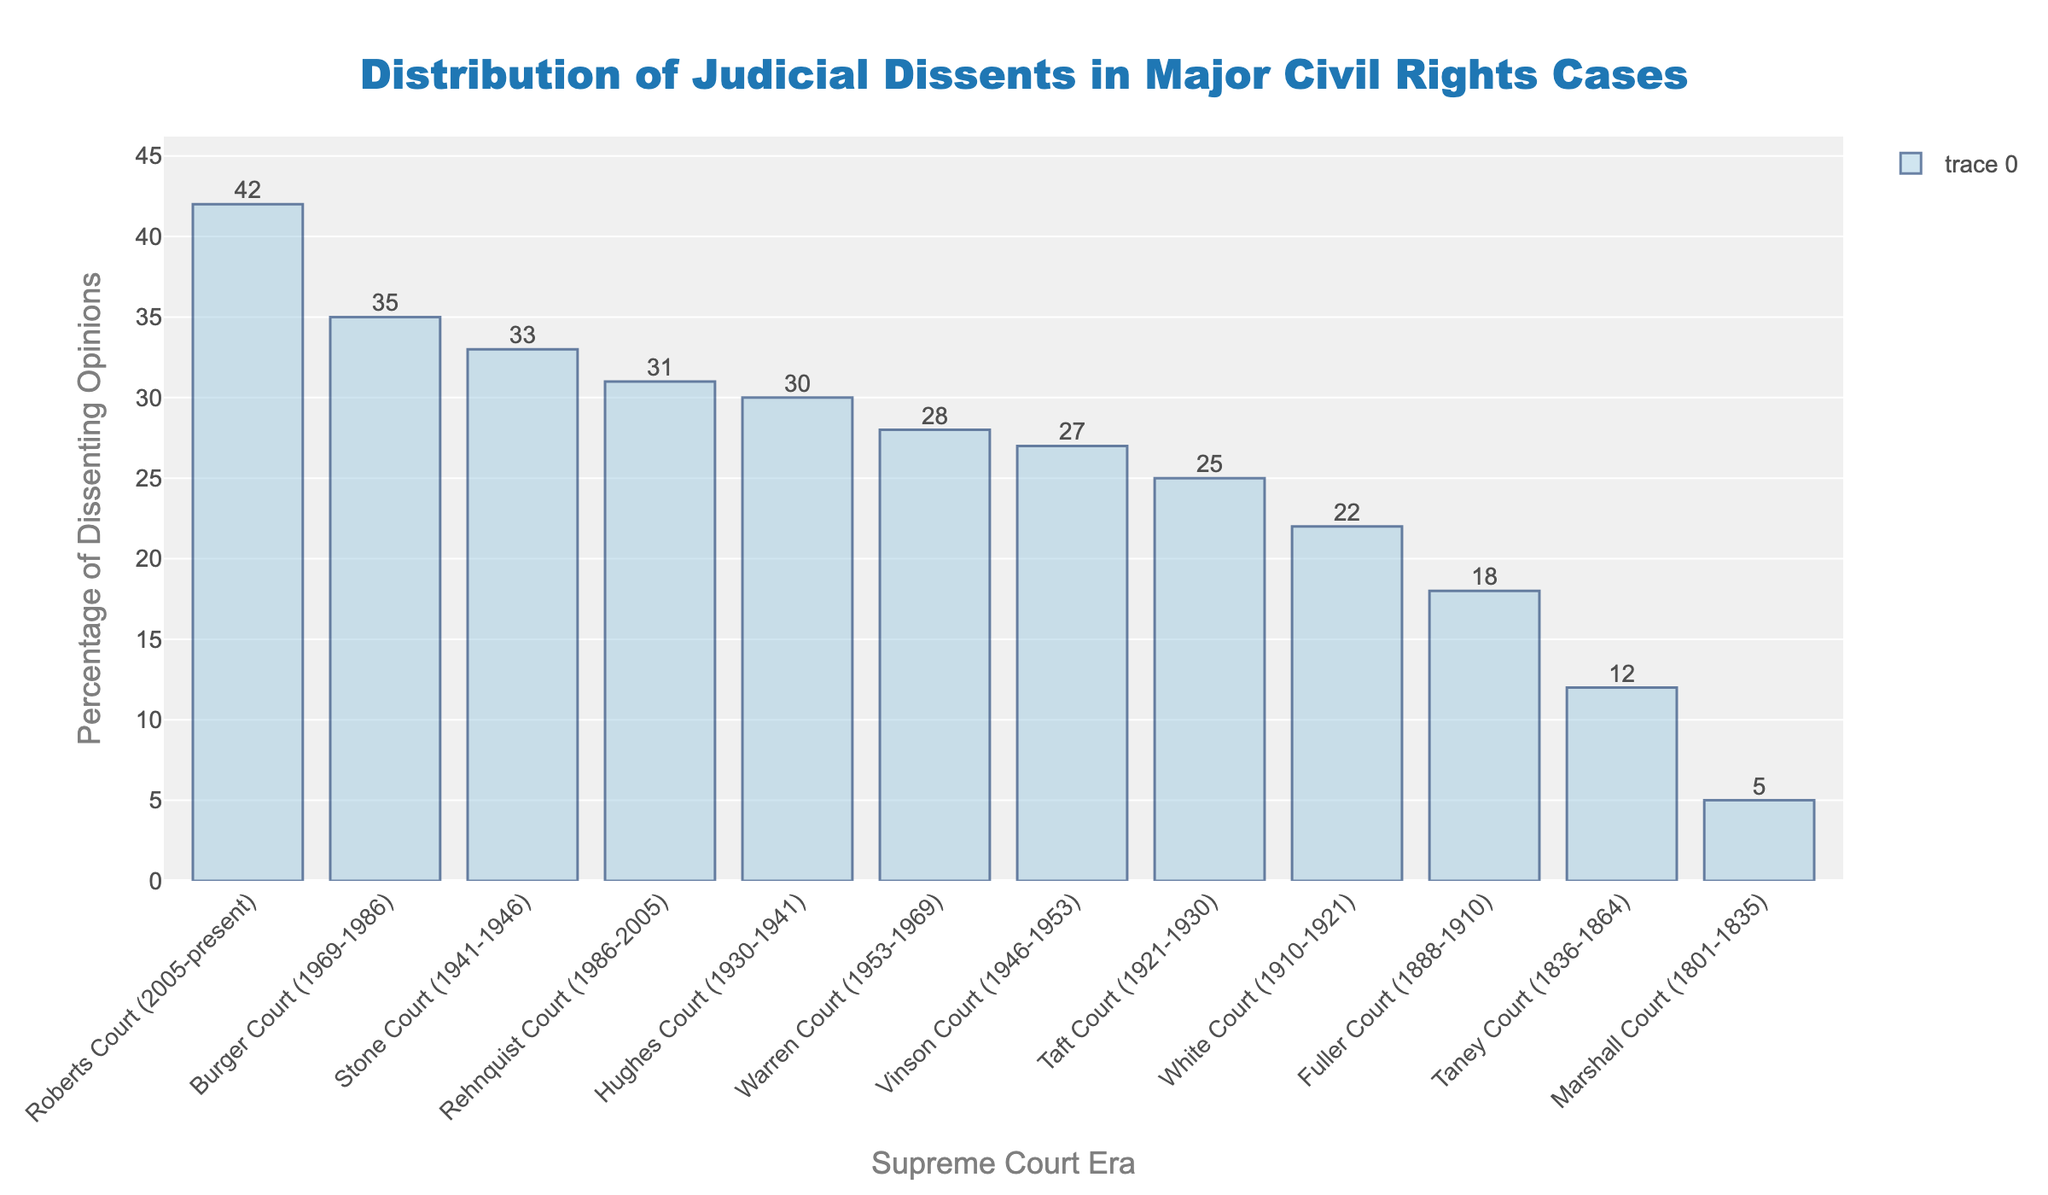Which Supreme Court era has the highest percentage of dissenting opinions? The highest bar in the chart represents the Roberts Court, with the label showing the percentage of dissenting opinions as 42%.
Answer: Roberts Court (2005-present) What is the difference in the percentage of dissenting opinions between the Warren Court and the Vinson Court? The chart shows the Warren Court has a percentage of 28% and the Vinson Court has 27%. The difference is calculated as 28 - 27.
Answer: 1% How does the percentage of dissenting opinions in the Rehnquist Court compare to the Hughes Court? According to the chart, the Rehnquist Court has a percentage of 31% while the Hughes Court has 30%. The Rehnquist Court has a slightly higher percentage than the Hughes Court.
Answer: The Rehnquist Court is 1% higher Which two Supreme Court eras have the closest percentage of dissenting opinions? By examining the chart, the Warren Court (28%) and the Vinson Court (27%) have the percentages that are closest to each other. The difference between their percentages is the smallest.
Answer: Warren Court and Vinson Court What is the combined percentage of dissenting opinions for the Marshall Court, Taney Court, and Fuller Court? The chart shows the Marshall Court with 5%, Taney Court with 12%, and Fuller Court with 18%. Adding these together gives 5 + 12 + 18.
Answer: 35% Which era has the least percentage of dissenting opinions, and what is that percentage? The shortest bar in the chart represents the Marshall Court, which has the percentage label of 5%.
Answer: Marshall Court (1801-1835), 5% How much higher is the percentage of dissenting opinions in the Roberts Court compared to the Marshall Court? The chart indicates that the Roberts Court has a percentage of 42% while the Marshall Court has 5%. To find the difference, calculate 42 - 5.
Answer: 37% What is the average percentage of dissenting opinions across all Supreme Court eras depicted in the chart? Add up all the percentages: 28 + 35 + 31 + 42 + 5 + 12 + 18 + 22 + 25 + 30 + 33 + 27 = 308. There are 12 eras, so divide 308 by 12.
Answer: 25.67% Between the Taft Court and the Hughes Court, which has a higher percentage of dissenting opinions, and by how much? The chart shows the Taft Court with 25% and the Hughes Court with 30%. The Hughes Court has 5% more than the Taft Court.
Answer: Hughes Court, 5% higher 